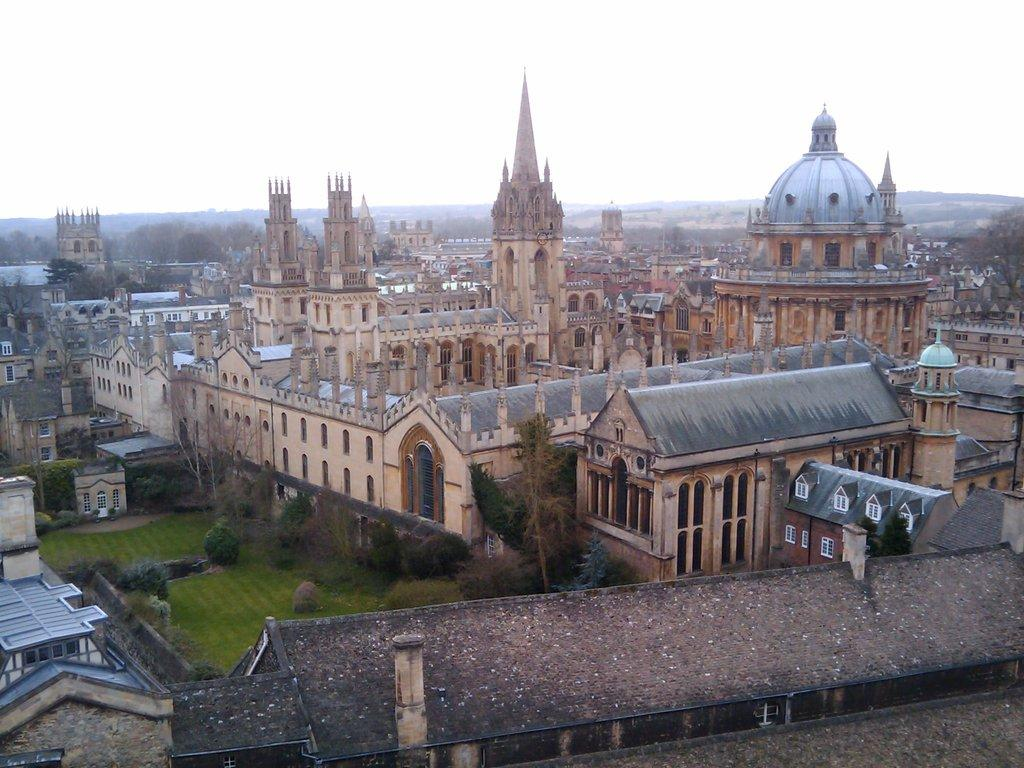What type of view is shown in the image? The image is an aerial view of a city. What can be seen in the foreground of the image? There are buildings, trees, and grass in the foreground of the image. What is visible in the background of the image? There are trees and buildings in the background of the image. What is the condition of the sky in the image? The sky is cloudy in the image. What type of question is being asked in the image? There is no question being asked in the image; it is a photograph of a city from an aerial perspective. 